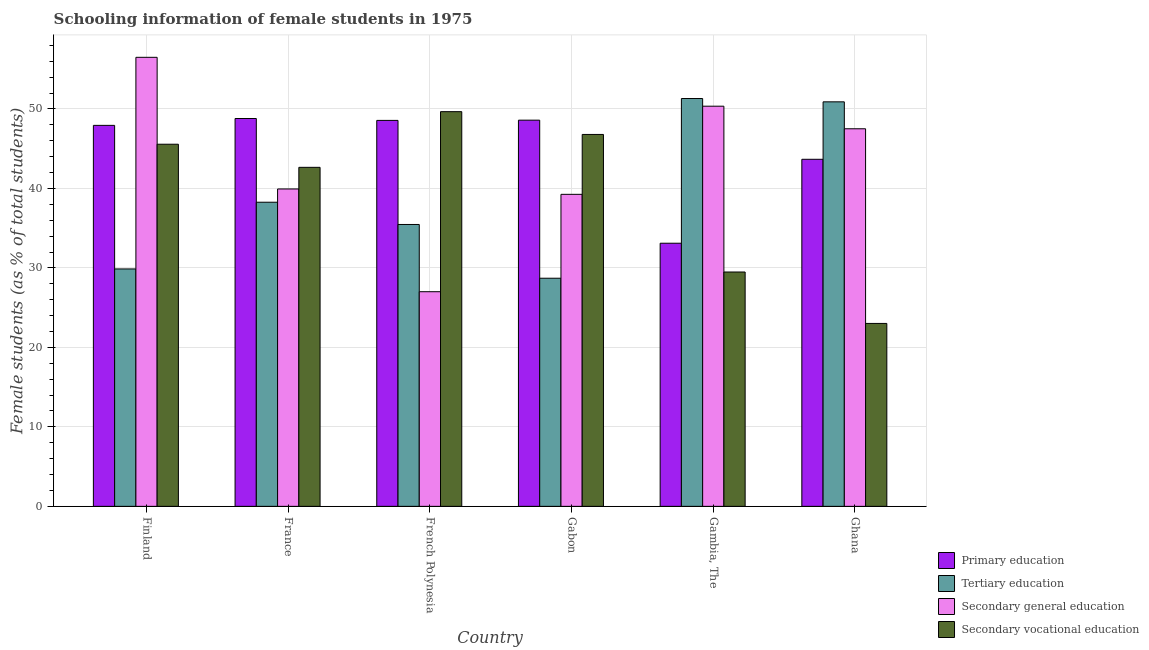How many different coloured bars are there?
Your response must be concise. 4. Are the number of bars on each tick of the X-axis equal?
Ensure brevity in your answer.  Yes. How many bars are there on the 1st tick from the left?
Your response must be concise. 4. How many bars are there on the 6th tick from the right?
Your answer should be very brief. 4. What is the label of the 1st group of bars from the left?
Make the answer very short. Finland. In how many cases, is the number of bars for a given country not equal to the number of legend labels?
Your answer should be very brief. 0. What is the percentage of female students in secondary vocational education in French Polynesia?
Keep it short and to the point. 49.66. Across all countries, what is the maximum percentage of female students in primary education?
Ensure brevity in your answer.  48.8. Across all countries, what is the minimum percentage of female students in secondary education?
Offer a very short reply. 27.01. In which country was the percentage of female students in secondary vocational education maximum?
Provide a succinct answer. French Polynesia. What is the total percentage of female students in secondary education in the graph?
Offer a very short reply. 260.57. What is the difference between the percentage of female students in secondary vocational education in France and that in Gambia, The?
Your answer should be compact. 13.17. What is the difference between the percentage of female students in tertiary education in Gambia, The and the percentage of female students in secondary vocational education in Gabon?
Offer a terse response. 4.52. What is the average percentage of female students in secondary education per country?
Your response must be concise. 43.43. What is the difference between the percentage of female students in secondary education and percentage of female students in primary education in Finland?
Your answer should be compact. 8.56. In how many countries, is the percentage of female students in tertiary education greater than 54 %?
Keep it short and to the point. 0. What is the ratio of the percentage of female students in secondary vocational education in Finland to that in French Polynesia?
Ensure brevity in your answer.  0.92. Is the percentage of female students in primary education in Finland less than that in Ghana?
Ensure brevity in your answer.  No. Is the difference between the percentage of female students in tertiary education in French Polynesia and Ghana greater than the difference between the percentage of female students in secondary vocational education in French Polynesia and Ghana?
Your answer should be compact. No. What is the difference between the highest and the second highest percentage of female students in tertiary education?
Your answer should be very brief. 0.42. What is the difference between the highest and the lowest percentage of female students in secondary vocational education?
Your answer should be compact. 26.65. Is it the case that in every country, the sum of the percentage of female students in tertiary education and percentage of female students in secondary vocational education is greater than the sum of percentage of female students in primary education and percentage of female students in secondary education?
Keep it short and to the point. Yes. What does the 3rd bar from the left in French Polynesia represents?
Offer a terse response. Secondary general education. What does the 3rd bar from the right in Finland represents?
Give a very brief answer. Tertiary education. How many bars are there?
Your response must be concise. 24. Are all the bars in the graph horizontal?
Your answer should be compact. No. How many countries are there in the graph?
Offer a terse response. 6. Are the values on the major ticks of Y-axis written in scientific E-notation?
Keep it short and to the point. No. Does the graph contain any zero values?
Keep it short and to the point. No. Does the graph contain grids?
Your response must be concise. Yes. How many legend labels are there?
Offer a very short reply. 4. What is the title of the graph?
Offer a terse response. Schooling information of female students in 1975. Does "Corruption" appear as one of the legend labels in the graph?
Your response must be concise. No. What is the label or title of the X-axis?
Your answer should be compact. Country. What is the label or title of the Y-axis?
Keep it short and to the point. Female students (as % of total students). What is the Female students (as % of total students) in Primary education in Finland?
Give a very brief answer. 47.94. What is the Female students (as % of total students) of Tertiary education in Finland?
Ensure brevity in your answer.  29.87. What is the Female students (as % of total students) of Secondary general education in Finland?
Offer a very short reply. 56.5. What is the Female students (as % of total students) of Secondary vocational education in Finland?
Your response must be concise. 45.57. What is the Female students (as % of total students) in Primary education in France?
Your answer should be compact. 48.8. What is the Female students (as % of total students) in Tertiary education in France?
Your answer should be very brief. 38.27. What is the Female students (as % of total students) of Secondary general education in France?
Ensure brevity in your answer.  39.94. What is the Female students (as % of total students) of Secondary vocational education in France?
Ensure brevity in your answer.  42.66. What is the Female students (as % of total students) in Primary education in French Polynesia?
Provide a short and direct response. 48.56. What is the Female students (as % of total students) of Tertiary education in French Polynesia?
Offer a very short reply. 35.47. What is the Female students (as % of total students) of Secondary general education in French Polynesia?
Ensure brevity in your answer.  27.01. What is the Female students (as % of total students) in Secondary vocational education in French Polynesia?
Give a very brief answer. 49.66. What is the Female students (as % of total students) in Primary education in Gabon?
Offer a very short reply. 48.59. What is the Female students (as % of total students) in Tertiary education in Gabon?
Offer a very short reply. 28.7. What is the Female students (as % of total students) in Secondary general education in Gabon?
Offer a terse response. 39.26. What is the Female students (as % of total students) of Secondary vocational education in Gabon?
Offer a terse response. 46.8. What is the Female students (as % of total students) in Primary education in Gambia, The?
Provide a succinct answer. 33.11. What is the Female students (as % of total students) of Tertiary education in Gambia, The?
Make the answer very short. 51.32. What is the Female students (as % of total students) in Secondary general education in Gambia, The?
Your answer should be very brief. 50.35. What is the Female students (as % of total students) in Secondary vocational education in Gambia, The?
Keep it short and to the point. 29.49. What is the Female students (as % of total students) in Primary education in Ghana?
Offer a terse response. 43.67. What is the Female students (as % of total students) of Tertiary education in Ghana?
Provide a short and direct response. 50.9. What is the Female students (as % of total students) of Secondary general education in Ghana?
Offer a very short reply. 47.51. What is the Female students (as % of total students) of Secondary vocational education in Ghana?
Provide a short and direct response. 23.02. Across all countries, what is the maximum Female students (as % of total students) of Primary education?
Keep it short and to the point. 48.8. Across all countries, what is the maximum Female students (as % of total students) in Tertiary education?
Keep it short and to the point. 51.32. Across all countries, what is the maximum Female students (as % of total students) in Secondary general education?
Offer a terse response. 56.5. Across all countries, what is the maximum Female students (as % of total students) in Secondary vocational education?
Offer a very short reply. 49.66. Across all countries, what is the minimum Female students (as % of total students) in Primary education?
Offer a very short reply. 33.11. Across all countries, what is the minimum Female students (as % of total students) of Tertiary education?
Make the answer very short. 28.7. Across all countries, what is the minimum Female students (as % of total students) in Secondary general education?
Provide a succinct answer. 27.01. Across all countries, what is the minimum Female students (as % of total students) of Secondary vocational education?
Give a very brief answer. 23.02. What is the total Female students (as % of total students) of Primary education in the graph?
Your response must be concise. 270.67. What is the total Female students (as % of total students) in Tertiary education in the graph?
Offer a terse response. 234.53. What is the total Female students (as % of total students) in Secondary general education in the graph?
Offer a very short reply. 260.57. What is the total Female students (as % of total students) of Secondary vocational education in the graph?
Provide a short and direct response. 237.18. What is the difference between the Female students (as % of total students) of Primary education in Finland and that in France?
Your answer should be compact. -0.86. What is the difference between the Female students (as % of total students) of Tertiary education in Finland and that in France?
Your answer should be very brief. -8.4. What is the difference between the Female students (as % of total students) of Secondary general education in Finland and that in France?
Provide a succinct answer. 16.56. What is the difference between the Female students (as % of total students) in Secondary vocational education in Finland and that in France?
Make the answer very short. 2.91. What is the difference between the Female students (as % of total students) in Primary education in Finland and that in French Polynesia?
Keep it short and to the point. -0.62. What is the difference between the Female students (as % of total students) of Tertiary education in Finland and that in French Polynesia?
Your answer should be very brief. -5.6. What is the difference between the Female students (as % of total students) of Secondary general education in Finland and that in French Polynesia?
Keep it short and to the point. 29.49. What is the difference between the Female students (as % of total students) of Secondary vocational education in Finland and that in French Polynesia?
Provide a succinct answer. -4.1. What is the difference between the Female students (as % of total students) of Primary education in Finland and that in Gabon?
Provide a succinct answer. -0.65. What is the difference between the Female students (as % of total students) of Tertiary education in Finland and that in Gabon?
Your response must be concise. 1.17. What is the difference between the Female students (as % of total students) in Secondary general education in Finland and that in Gabon?
Provide a succinct answer. 17.24. What is the difference between the Female students (as % of total students) in Secondary vocational education in Finland and that in Gabon?
Your answer should be very brief. -1.23. What is the difference between the Female students (as % of total students) in Primary education in Finland and that in Gambia, The?
Provide a succinct answer. 14.83. What is the difference between the Female students (as % of total students) of Tertiary education in Finland and that in Gambia, The?
Ensure brevity in your answer.  -21.44. What is the difference between the Female students (as % of total students) of Secondary general education in Finland and that in Gambia, The?
Keep it short and to the point. 6.15. What is the difference between the Female students (as % of total students) of Secondary vocational education in Finland and that in Gambia, The?
Your answer should be very brief. 16.08. What is the difference between the Female students (as % of total students) in Primary education in Finland and that in Ghana?
Keep it short and to the point. 4.27. What is the difference between the Female students (as % of total students) in Tertiary education in Finland and that in Ghana?
Offer a very short reply. -21.03. What is the difference between the Female students (as % of total students) in Secondary general education in Finland and that in Ghana?
Provide a short and direct response. 8.99. What is the difference between the Female students (as % of total students) in Secondary vocational education in Finland and that in Ghana?
Provide a short and direct response. 22.55. What is the difference between the Female students (as % of total students) in Primary education in France and that in French Polynesia?
Give a very brief answer. 0.24. What is the difference between the Female students (as % of total students) in Tertiary education in France and that in French Polynesia?
Your response must be concise. 2.8. What is the difference between the Female students (as % of total students) in Secondary general education in France and that in French Polynesia?
Offer a very short reply. 12.93. What is the difference between the Female students (as % of total students) of Secondary vocational education in France and that in French Polynesia?
Your answer should be compact. -7.01. What is the difference between the Female students (as % of total students) in Primary education in France and that in Gabon?
Provide a short and direct response. 0.21. What is the difference between the Female students (as % of total students) in Tertiary education in France and that in Gabon?
Make the answer very short. 9.56. What is the difference between the Female students (as % of total students) of Secondary general education in France and that in Gabon?
Provide a short and direct response. 0.68. What is the difference between the Female students (as % of total students) in Secondary vocational education in France and that in Gabon?
Keep it short and to the point. -4.14. What is the difference between the Female students (as % of total students) in Primary education in France and that in Gambia, The?
Your answer should be very brief. 15.69. What is the difference between the Female students (as % of total students) in Tertiary education in France and that in Gambia, The?
Offer a terse response. -13.05. What is the difference between the Female students (as % of total students) of Secondary general education in France and that in Gambia, The?
Provide a succinct answer. -10.41. What is the difference between the Female students (as % of total students) of Secondary vocational education in France and that in Gambia, The?
Offer a terse response. 13.17. What is the difference between the Female students (as % of total students) of Primary education in France and that in Ghana?
Offer a very short reply. 5.13. What is the difference between the Female students (as % of total students) of Tertiary education in France and that in Ghana?
Provide a short and direct response. -12.63. What is the difference between the Female students (as % of total students) in Secondary general education in France and that in Ghana?
Your answer should be very brief. -7.57. What is the difference between the Female students (as % of total students) of Secondary vocational education in France and that in Ghana?
Give a very brief answer. 19.64. What is the difference between the Female students (as % of total students) of Primary education in French Polynesia and that in Gabon?
Your response must be concise. -0.03. What is the difference between the Female students (as % of total students) in Tertiary education in French Polynesia and that in Gabon?
Ensure brevity in your answer.  6.76. What is the difference between the Female students (as % of total students) in Secondary general education in French Polynesia and that in Gabon?
Your answer should be very brief. -12.25. What is the difference between the Female students (as % of total students) of Secondary vocational education in French Polynesia and that in Gabon?
Offer a terse response. 2.87. What is the difference between the Female students (as % of total students) of Primary education in French Polynesia and that in Gambia, The?
Keep it short and to the point. 15.46. What is the difference between the Female students (as % of total students) of Tertiary education in French Polynesia and that in Gambia, The?
Provide a succinct answer. -15.85. What is the difference between the Female students (as % of total students) in Secondary general education in French Polynesia and that in Gambia, The?
Ensure brevity in your answer.  -23.34. What is the difference between the Female students (as % of total students) in Secondary vocational education in French Polynesia and that in Gambia, The?
Offer a very short reply. 20.18. What is the difference between the Female students (as % of total students) in Primary education in French Polynesia and that in Ghana?
Offer a very short reply. 4.89. What is the difference between the Female students (as % of total students) in Tertiary education in French Polynesia and that in Ghana?
Offer a terse response. -15.43. What is the difference between the Female students (as % of total students) of Secondary general education in French Polynesia and that in Ghana?
Make the answer very short. -20.5. What is the difference between the Female students (as % of total students) of Secondary vocational education in French Polynesia and that in Ghana?
Offer a terse response. 26.65. What is the difference between the Female students (as % of total students) of Primary education in Gabon and that in Gambia, The?
Provide a short and direct response. 15.49. What is the difference between the Female students (as % of total students) of Tertiary education in Gabon and that in Gambia, The?
Your answer should be very brief. -22.61. What is the difference between the Female students (as % of total students) of Secondary general education in Gabon and that in Gambia, The?
Your answer should be compact. -11.09. What is the difference between the Female students (as % of total students) in Secondary vocational education in Gabon and that in Gambia, The?
Give a very brief answer. 17.31. What is the difference between the Female students (as % of total students) in Primary education in Gabon and that in Ghana?
Offer a terse response. 4.92. What is the difference between the Female students (as % of total students) of Tertiary education in Gabon and that in Ghana?
Provide a succinct answer. -22.2. What is the difference between the Female students (as % of total students) in Secondary general education in Gabon and that in Ghana?
Provide a short and direct response. -8.25. What is the difference between the Female students (as % of total students) of Secondary vocational education in Gabon and that in Ghana?
Your answer should be very brief. 23.78. What is the difference between the Female students (as % of total students) of Primary education in Gambia, The and that in Ghana?
Offer a very short reply. -10.56. What is the difference between the Female students (as % of total students) of Tertiary education in Gambia, The and that in Ghana?
Provide a short and direct response. 0.42. What is the difference between the Female students (as % of total students) of Secondary general education in Gambia, The and that in Ghana?
Your answer should be compact. 2.84. What is the difference between the Female students (as % of total students) in Secondary vocational education in Gambia, The and that in Ghana?
Offer a very short reply. 6.47. What is the difference between the Female students (as % of total students) in Primary education in Finland and the Female students (as % of total students) in Tertiary education in France?
Offer a very short reply. 9.67. What is the difference between the Female students (as % of total students) of Primary education in Finland and the Female students (as % of total students) of Secondary general education in France?
Your answer should be very brief. 8. What is the difference between the Female students (as % of total students) of Primary education in Finland and the Female students (as % of total students) of Secondary vocational education in France?
Provide a succinct answer. 5.28. What is the difference between the Female students (as % of total students) in Tertiary education in Finland and the Female students (as % of total students) in Secondary general education in France?
Provide a short and direct response. -10.07. What is the difference between the Female students (as % of total students) of Tertiary education in Finland and the Female students (as % of total students) of Secondary vocational education in France?
Your answer should be very brief. -12.79. What is the difference between the Female students (as % of total students) of Secondary general education in Finland and the Female students (as % of total students) of Secondary vocational education in France?
Offer a terse response. 13.84. What is the difference between the Female students (as % of total students) in Primary education in Finland and the Female students (as % of total students) in Tertiary education in French Polynesia?
Keep it short and to the point. 12.47. What is the difference between the Female students (as % of total students) in Primary education in Finland and the Female students (as % of total students) in Secondary general education in French Polynesia?
Give a very brief answer. 20.93. What is the difference between the Female students (as % of total students) in Primary education in Finland and the Female students (as % of total students) in Secondary vocational education in French Polynesia?
Your response must be concise. -1.72. What is the difference between the Female students (as % of total students) in Tertiary education in Finland and the Female students (as % of total students) in Secondary general education in French Polynesia?
Give a very brief answer. 2.86. What is the difference between the Female students (as % of total students) in Tertiary education in Finland and the Female students (as % of total students) in Secondary vocational education in French Polynesia?
Ensure brevity in your answer.  -19.79. What is the difference between the Female students (as % of total students) of Secondary general education in Finland and the Female students (as % of total students) of Secondary vocational education in French Polynesia?
Make the answer very short. 6.84. What is the difference between the Female students (as % of total students) of Primary education in Finland and the Female students (as % of total students) of Tertiary education in Gabon?
Provide a short and direct response. 19.24. What is the difference between the Female students (as % of total students) of Primary education in Finland and the Female students (as % of total students) of Secondary general education in Gabon?
Your answer should be compact. 8.68. What is the difference between the Female students (as % of total students) in Tertiary education in Finland and the Female students (as % of total students) in Secondary general education in Gabon?
Your response must be concise. -9.39. What is the difference between the Female students (as % of total students) of Tertiary education in Finland and the Female students (as % of total students) of Secondary vocational education in Gabon?
Provide a short and direct response. -16.92. What is the difference between the Female students (as % of total students) in Secondary general education in Finland and the Female students (as % of total students) in Secondary vocational education in Gabon?
Your answer should be very brief. 9.7. What is the difference between the Female students (as % of total students) of Primary education in Finland and the Female students (as % of total students) of Tertiary education in Gambia, The?
Your answer should be compact. -3.38. What is the difference between the Female students (as % of total students) in Primary education in Finland and the Female students (as % of total students) in Secondary general education in Gambia, The?
Your answer should be compact. -2.41. What is the difference between the Female students (as % of total students) in Primary education in Finland and the Female students (as % of total students) in Secondary vocational education in Gambia, The?
Offer a very short reply. 18.45. What is the difference between the Female students (as % of total students) in Tertiary education in Finland and the Female students (as % of total students) in Secondary general education in Gambia, The?
Provide a succinct answer. -20.48. What is the difference between the Female students (as % of total students) in Tertiary education in Finland and the Female students (as % of total students) in Secondary vocational education in Gambia, The?
Provide a short and direct response. 0.38. What is the difference between the Female students (as % of total students) in Secondary general education in Finland and the Female students (as % of total students) in Secondary vocational education in Gambia, The?
Keep it short and to the point. 27.01. What is the difference between the Female students (as % of total students) of Primary education in Finland and the Female students (as % of total students) of Tertiary education in Ghana?
Offer a terse response. -2.96. What is the difference between the Female students (as % of total students) of Primary education in Finland and the Female students (as % of total students) of Secondary general education in Ghana?
Make the answer very short. 0.43. What is the difference between the Female students (as % of total students) in Primary education in Finland and the Female students (as % of total students) in Secondary vocational education in Ghana?
Keep it short and to the point. 24.92. What is the difference between the Female students (as % of total students) of Tertiary education in Finland and the Female students (as % of total students) of Secondary general education in Ghana?
Your response must be concise. -17.64. What is the difference between the Female students (as % of total students) of Tertiary education in Finland and the Female students (as % of total students) of Secondary vocational education in Ghana?
Your answer should be very brief. 6.86. What is the difference between the Female students (as % of total students) of Secondary general education in Finland and the Female students (as % of total students) of Secondary vocational education in Ghana?
Make the answer very short. 33.48. What is the difference between the Female students (as % of total students) in Primary education in France and the Female students (as % of total students) in Tertiary education in French Polynesia?
Provide a succinct answer. 13.33. What is the difference between the Female students (as % of total students) in Primary education in France and the Female students (as % of total students) in Secondary general education in French Polynesia?
Offer a very short reply. 21.79. What is the difference between the Female students (as % of total students) in Primary education in France and the Female students (as % of total students) in Secondary vocational education in French Polynesia?
Your answer should be compact. -0.86. What is the difference between the Female students (as % of total students) in Tertiary education in France and the Female students (as % of total students) in Secondary general education in French Polynesia?
Your answer should be very brief. 11.26. What is the difference between the Female students (as % of total students) in Tertiary education in France and the Female students (as % of total students) in Secondary vocational education in French Polynesia?
Your answer should be very brief. -11.4. What is the difference between the Female students (as % of total students) of Secondary general education in France and the Female students (as % of total students) of Secondary vocational education in French Polynesia?
Offer a terse response. -9.73. What is the difference between the Female students (as % of total students) in Primary education in France and the Female students (as % of total students) in Tertiary education in Gabon?
Your response must be concise. 20.1. What is the difference between the Female students (as % of total students) in Primary education in France and the Female students (as % of total students) in Secondary general education in Gabon?
Provide a short and direct response. 9.54. What is the difference between the Female students (as % of total students) in Primary education in France and the Female students (as % of total students) in Secondary vocational education in Gabon?
Your answer should be very brief. 2.01. What is the difference between the Female students (as % of total students) in Tertiary education in France and the Female students (as % of total students) in Secondary general education in Gabon?
Your response must be concise. -0.99. What is the difference between the Female students (as % of total students) of Tertiary education in France and the Female students (as % of total students) of Secondary vocational education in Gabon?
Your response must be concise. -8.53. What is the difference between the Female students (as % of total students) of Secondary general education in France and the Female students (as % of total students) of Secondary vocational education in Gabon?
Ensure brevity in your answer.  -6.86. What is the difference between the Female students (as % of total students) of Primary education in France and the Female students (as % of total students) of Tertiary education in Gambia, The?
Offer a very short reply. -2.51. What is the difference between the Female students (as % of total students) in Primary education in France and the Female students (as % of total students) in Secondary general education in Gambia, The?
Your answer should be very brief. -1.55. What is the difference between the Female students (as % of total students) of Primary education in France and the Female students (as % of total students) of Secondary vocational education in Gambia, The?
Make the answer very short. 19.31. What is the difference between the Female students (as % of total students) in Tertiary education in France and the Female students (as % of total students) in Secondary general education in Gambia, The?
Offer a terse response. -12.08. What is the difference between the Female students (as % of total students) in Tertiary education in France and the Female students (as % of total students) in Secondary vocational education in Gambia, The?
Your response must be concise. 8.78. What is the difference between the Female students (as % of total students) of Secondary general education in France and the Female students (as % of total students) of Secondary vocational education in Gambia, The?
Provide a short and direct response. 10.45. What is the difference between the Female students (as % of total students) of Primary education in France and the Female students (as % of total students) of Tertiary education in Ghana?
Offer a very short reply. -2.1. What is the difference between the Female students (as % of total students) in Primary education in France and the Female students (as % of total students) in Secondary general education in Ghana?
Your answer should be very brief. 1.29. What is the difference between the Female students (as % of total students) in Primary education in France and the Female students (as % of total students) in Secondary vocational education in Ghana?
Give a very brief answer. 25.79. What is the difference between the Female students (as % of total students) in Tertiary education in France and the Female students (as % of total students) in Secondary general education in Ghana?
Provide a short and direct response. -9.24. What is the difference between the Female students (as % of total students) of Tertiary education in France and the Female students (as % of total students) of Secondary vocational education in Ghana?
Give a very brief answer. 15.25. What is the difference between the Female students (as % of total students) of Secondary general education in France and the Female students (as % of total students) of Secondary vocational education in Ghana?
Your answer should be very brief. 16.92. What is the difference between the Female students (as % of total students) in Primary education in French Polynesia and the Female students (as % of total students) in Tertiary education in Gabon?
Ensure brevity in your answer.  19.86. What is the difference between the Female students (as % of total students) in Primary education in French Polynesia and the Female students (as % of total students) in Secondary general education in Gabon?
Give a very brief answer. 9.3. What is the difference between the Female students (as % of total students) of Primary education in French Polynesia and the Female students (as % of total students) of Secondary vocational education in Gabon?
Ensure brevity in your answer.  1.77. What is the difference between the Female students (as % of total students) of Tertiary education in French Polynesia and the Female students (as % of total students) of Secondary general education in Gabon?
Offer a very short reply. -3.79. What is the difference between the Female students (as % of total students) in Tertiary education in French Polynesia and the Female students (as % of total students) in Secondary vocational education in Gabon?
Give a very brief answer. -11.33. What is the difference between the Female students (as % of total students) in Secondary general education in French Polynesia and the Female students (as % of total students) in Secondary vocational education in Gabon?
Your answer should be compact. -19.79. What is the difference between the Female students (as % of total students) in Primary education in French Polynesia and the Female students (as % of total students) in Tertiary education in Gambia, The?
Keep it short and to the point. -2.75. What is the difference between the Female students (as % of total students) of Primary education in French Polynesia and the Female students (as % of total students) of Secondary general education in Gambia, The?
Your answer should be very brief. -1.79. What is the difference between the Female students (as % of total students) in Primary education in French Polynesia and the Female students (as % of total students) in Secondary vocational education in Gambia, The?
Make the answer very short. 19.08. What is the difference between the Female students (as % of total students) in Tertiary education in French Polynesia and the Female students (as % of total students) in Secondary general education in Gambia, The?
Your answer should be compact. -14.88. What is the difference between the Female students (as % of total students) in Tertiary education in French Polynesia and the Female students (as % of total students) in Secondary vocational education in Gambia, The?
Your answer should be compact. 5.98. What is the difference between the Female students (as % of total students) of Secondary general education in French Polynesia and the Female students (as % of total students) of Secondary vocational education in Gambia, The?
Provide a succinct answer. -2.48. What is the difference between the Female students (as % of total students) of Primary education in French Polynesia and the Female students (as % of total students) of Tertiary education in Ghana?
Your answer should be very brief. -2.34. What is the difference between the Female students (as % of total students) of Primary education in French Polynesia and the Female students (as % of total students) of Secondary general education in Ghana?
Offer a very short reply. 1.05. What is the difference between the Female students (as % of total students) of Primary education in French Polynesia and the Female students (as % of total students) of Secondary vocational education in Ghana?
Your response must be concise. 25.55. What is the difference between the Female students (as % of total students) in Tertiary education in French Polynesia and the Female students (as % of total students) in Secondary general education in Ghana?
Offer a terse response. -12.04. What is the difference between the Female students (as % of total students) in Tertiary education in French Polynesia and the Female students (as % of total students) in Secondary vocational education in Ghana?
Keep it short and to the point. 12.45. What is the difference between the Female students (as % of total students) of Secondary general education in French Polynesia and the Female students (as % of total students) of Secondary vocational education in Ghana?
Provide a short and direct response. 3.99. What is the difference between the Female students (as % of total students) in Primary education in Gabon and the Female students (as % of total students) in Tertiary education in Gambia, The?
Your response must be concise. -2.72. What is the difference between the Female students (as % of total students) in Primary education in Gabon and the Female students (as % of total students) in Secondary general education in Gambia, The?
Your answer should be compact. -1.76. What is the difference between the Female students (as % of total students) of Primary education in Gabon and the Female students (as % of total students) of Secondary vocational education in Gambia, The?
Your response must be concise. 19.11. What is the difference between the Female students (as % of total students) in Tertiary education in Gabon and the Female students (as % of total students) in Secondary general education in Gambia, The?
Provide a succinct answer. -21.65. What is the difference between the Female students (as % of total students) in Tertiary education in Gabon and the Female students (as % of total students) in Secondary vocational education in Gambia, The?
Your answer should be very brief. -0.78. What is the difference between the Female students (as % of total students) of Secondary general education in Gabon and the Female students (as % of total students) of Secondary vocational education in Gambia, The?
Keep it short and to the point. 9.77. What is the difference between the Female students (as % of total students) of Primary education in Gabon and the Female students (as % of total students) of Tertiary education in Ghana?
Keep it short and to the point. -2.31. What is the difference between the Female students (as % of total students) in Primary education in Gabon and the Female students (as % of total students) in Secondary general education in Ghana?
Offer a terse response. 1.08. What is the difference between the Female students (as % of total students) in Primary education in Gabon and the Female students (as % of total students) in Secondary vocational education in Ghana?
Keep it short and to the point. 25.58. What is the difference between the Female students (as % of total students) of Tertiary education in Gabon and the Female students (as % of total students) of Secondary general education in Ghana?
Your answer should be very brief. -18.81. What is the difference between the Female students (as % of total students) of Tertiary education in Gabon and the Female students (as % of total students) of Secondary vocational education in Ghana?
Ensure brevity in your answer.  5.69. What is the difference between the Female students (as % of total students) of Secondary general education in Gabon and the Female students (as % of total students) of Secondary vocational education in Ghana?
Provide a succinct answer. 16.25. What is the difference between the Female students (as % of total students) in Primary education in Gambia, The and the Female students (as % of total students) in Tertiary education in Ghana?
Provide a short and direct response. -17.79. What is the difference between the Female students (as % of total students) of Primary education in Gambia, The and the Female students (as % of total students) of Secondary general education in Ghana?
Provide a short and direct response. -14.4. What is the difference between the Female students (as % of total students) of Primary education in Gambia, The and the Female students (as % of total students) of Secondary vocational education in Ghana?
Your response must be concise. 10.09. What is the difference between the Female students (as % of total students) of Tertiary education in Gambia, The and the Female students (as % of total students) of Secondary general education in Ghana?
Make the answer very short. 3.81. What is the difference between the Female students (as % of total students) in Tertiary education in Gambia, The and the Female students (as % of total students) in Secondary vocational education in Ghana?
Your response must be concise. 28.3. What is the difference between the Female students (as % of total students) of Secondary general education in Gambia, The and the Female students (as % of total students) of Secondary vocational education in Ghana?
Offer a very short reply. 27.34. What is the average Female students (as % of total students) of Primary education per country?
Give a very brief answer. 45.11. What is the average Female students (as % of total students) in Tertiary education per country?
Provide a succinct answer. 39.09. What is the average Female students (as % of total students) of Secondary general education per country?
Make the answer very short. 43.43. What is the average Female students (as % of total students) of Secondary vocational education per country?
Keep it short and to the point. 39.53. What is the difference between the Female students (as % of total students) in Primary education and Female students (as % of total students) in Tertiary education in Finland?
Make the answer very short. 18.07. What is the difference between the Female students (as % of total students) in Primary education and Female students (as % of total students) in Secondary general education in Finland?
Keep it short and to the point. -8.56. What is the difference between the Female students (as % of total students) in Primary education and Female students (as % of total students) in Secondary vocational education in Finland?
Your answer should be compact. 2.37. What is the difference between the Female students (as % of total students) of Tertiary education and Female students (as % of total students) of Secondary general education in Finland?
Your answer should be compact. -26.63. What is the difference between the Female students (as % of total students) in Tertiary education and Female students (as % of total students) in Secondary vocational education in Finland?
Provide a succinct answer. -15.69. What is the difference between the Female students (as % of total students) in Secondary general education and Female students (as % of total students) in Secondary vocational education in Finland?
Your response must be concise. 10.94. What is the difference between the Female students (as % of total students) in Primary education and Female students (as % of total students) in Tertiary education in France?
Provide a short and direct response. 10.53. What is the difference between the Female students (as % of total students) of Primary education and Female students (as % of total students) of Secondary general education in France?
Offer a very short reply. 8.86. What is the difference between the Female students (as % of total students) of Primary education and Female students (as % of total students) of Secondary vocational education in France?
Offer a very short reply. 6.14. What is the difference between the Female students (as % of total students) in Tertiary education and Female students (as % of total students) in Secondary general education in France?
Your response must be concise. -1.67. What is the difference between the Female students (as % of total students) of Tertiary education and Female students (as % of total students) of Secondary vocational education in France?
Give a very brief answer. -4.39. What is the difference between the Female students (as % of total students) in Secondary general education and Female students (as % of total students) in Secondary vocational education in France?
Your response must be concise. -2.72. What is the difference between the Female students (as % of total students) of Primary education and Female students (as % of total students) of Tertiary education in French Polynesia?
Ensure brevity in your answer.  13.1. What is the difference between the Female students (as % of total students) of Primary education and Female students (as % of total students) of Secondary general education in French Polynesia?
Your answer should be compact. 21.56. What is the difference between the Female students (as % of total students) of Primary education and Female students (as % of total students) of Secondary vocational education in French Polynesia?
Offer a terse response. -1.1. What is the difference between the Female students (as % of total students) of Tertiary education and Female students (as % of total students) of Secondary general education in French Polynesia?
Keep it short and to the point. 8.46. What is the difference between the Female students (as % of total students) in Tertiary education and Female students (as % of total students) in Secondary vocational education in French Polynesia?
Offer a terse response. -14.2. What is the difference between the Female students (as % of total students) in Secondary general education and Female students (as % of total students) in Secondary vocational education in French Polynesia?
Make the answer very short. -22.66. What is the difference between the Female students (as % of total students) in Primary education and Female students (as % of total students) in Tertiary education in Gabon?
Offer a very short reply. 19.89. What is the difference between the Female students (as % of total students) in Primary education and Female students (as % of total students) in Secondary general education in Gabon?
Offer a very short reply. 9.33. What is the difference between the Female students (as % of total students) in Primary education and Female students (as % of total students) in Secondary vocational education in Gabon?
Provide a short and direct response. 1.8. What is the difference between the Female students (as % of total students) of Tertiary education and Female students (as % of total students) of Secondary general education in Gabon?
Your response must be concise. -10.56. What is the difference between the Female students (as % of total students) of Tertiary education and Female students (as % of total students) of Secondary vocational education in Gabon?
Your response must be concise. -18.09. What is the difference between the Female students (as % of total students) of Secondary general education and Female students (as % of total students) of Secondary vocational education in Gabon?
Offer a very short reply. -7.53. What is the difference between the Female students (as % of total students) of Primary education and Female students (as % of total students) of Tertiary education in Gambia, The?
Ensure brevity in your answer.  -18.21. What is the difference between the Female students (as % of total students) of Primary education and Female students (as % of total students) of Secondary general education in Gambia, The?
Offer a very short reply. -17.24. What is the difference between the Female students (as % of total students) in Primary education and Female students (as % of total students) in Secondary vocational education in Gambia, The?
Keep it short and to the point. 3.62. What is the difference between the Female students (as % of total students) in Tertiary education and Female students (as % of total students) in Secondary general education in Gambia, The?
Offer a terse response. 0.96. What is the difference between the Female students (as % of total students) of Tertiary education and Female students (as % of total students) of Secondary vocational education in Gambia, The?
Make the answer very short. 21.83. What is the difference between the Female students (as % of total students) of Secondary general education and Female students (as % of total students) of Secondary vocational education in Gambia, The?
Keep it short and to the point. 20.86. What is the difference between the Female students (as % of total students) of Primary education and Female students (as % of total students) of Tertiary education in Ghana?
Offer a terse response. -7.23. What is the difference between the Female students (as % of total students) of Primary education and Female students (as % of total students) of Secondary general education in Ghana?
Ensure brevity in your answer.  -3.84. What is the difference between the Female students (as % of total students) in Primary education and Female students (as % of total students) in Secondary vocational education in Ghana?
Provide a short and direct response. 20.65. What is the difference between the Female students (as % of total students) in Tertiary education and Female students (as % of total students) in Secondary general education in Ghana?
Keep it short and to the point. 3.39. What is the difference between the Female students (as % of total students) in Tertiary education and Female students (as % of total students) in Secondary vocational education in Ghana?
Your answer should be very brief. 27.88. What is the difference between the Female students (as % of total students) in Secondary general education and Female students (as % of total students) in Secondary vocational education in Ghana?
Provide a short and direct response. 24.49. What is the ratio of the Female students (as % of total students) of Primary education in Finland to that in France?
Your answer should be very brief. 0.98. What is the ratio of the Female students (as % of total students) of Tertiary education in Finland to that in France?
Provide a short and direct response. 0.78. What is the ratio of the Female students (as % of total students) in Secondary general education in Finland to that in France?
Make the answer very short. 1.41. What is the ratio of the Female students (as % of total students) of Secondary vocational education in Finland to that in France?
Your answer should be compact. 1.07. What is the ratio of the Female students (as % of total students) in Primary education in Finland to that in French Polynesia?
Your answer should be compact. 0.99. What is the ratio of the Female students (as % of total students) of Tertiary education in Finland to that in French Polynesia?
Provide a succinct answer. 0.84. What is the ratio of the Female students (as % of total students) in Secondary general education in Finland to that in French Polynesia?
Keep it short and to the point. 2.09. What is the ratio of the Female students (as % of total students) in Secondary vocational education in Finland to that in French Polynesia?
Offer a terse response. 0.92. What is the ratio of the Female students (as % of total students) in Primary education in Finland to that in Gabon?
Your answer should be compact. 0.99. What is the ratio of the Female students (as % of total students) of Tertiary education in Finland to that in Gabon?
Offer a terse response. 1.04. What is the ratio of the Female students (as % of total students) in Secondary general education in Finland to that in Gabon?
Provide a short and direct response. 1.44. What is the ratio of the Female students (as % of total students) in Secondary vocational education in Finland to that in Gabon?
Your response must be concise. 0.97. What is the ratio of the Female students (as % of total students) in Primary education in Finland to that in Gambia, The?
Your answer should be compact. 1.45. What is the ratio of the Female students (as % of total students) of Tertiary education in Finland to that in Gambia, The?
Provide a succinct answer. 0.58. What is the ratio of the Female students (as % of total students) in Secondary general education in Finland to that in Gambia, The?
Give a very brief answer. 1.12. What is the ratio of the Female students (as % of total students) in Secondary vocational education in Finland to that in Gambia, The?
Provide a succinct answer. 1.55. What is the ratio of the Female students (as % of total students) in Primary education in Finland to that in Ghana?
Offer a very short reply. 1.1. What is the ratio of the Female students (as % of total students) of Tertiary education in Finland to that in Ghana?
Provide a short and direct response. 0.59. What is the ratio of the Female students (as % of total students) of Secondary general education in Finland to that in Ghana?
Your answer should be compact. 1.19. What is the ratio of the Female students (as % of total students) in Secondary vocational education in Finland to that in Ghana?
Your answer should be very brief. 1.98. What is the ratio of the Female students (as % of total students) of Tertiary education in France to that in French Polynesia?
Give a very brief answer. 1.08. What is the ratio of the Female students (as % of total students) of Secondary general education in France to that in French Polynesia?
Make the answer very short. 1.48. What is the ratio of the Female students (as % of total students) of Secondary vocational education in France to that in French Polynesia?
Your response must be concise. 0.86. What is the ratio of the Female students (as % of total students) of Tertiary education in France to that in Gabon?
Your answer should be very brief. 1.33. What is the ratio of the Female students (as % of total students) in Secondary general education in France to that in Gabon?
Provide a succinct answer. 1.02. What is the ratio of the Female students (as % of total students) in Secondary vocational education in France to that in Gabon?
Give a very brief answer. 0.91. What is the ratio of the Female students (as % of total students) in Primary education in France to that in Gambia, The?
Make the answer very short. 1.47. What is the ratio of the Female students (as % of total students) in Tertiary education in France to that in Gambia, The?
Provide a succinct answer. 0.75. What is the ratio of the Female students (as % of total students) in Secondary general education in France to that in Gambia, The?
Your answer should be very brief. 0.79. What is the ratio of the Female students (as % of total students) in Secondary vocational education in France to that in Gambia, The?
Your answer should be very brief. 1.45. What is the ratio of the Female students (as % of total students) of Primary education in France to that in Ghana?
Your answer should be very brief. 1.12. What is the ratio of the Female students (as % of total students) of Tertiary education in France to that in Ghana?
Provide a short and direct response. 0.75. What is the ratio of the Female students (as % of total students) of Secondary general education in France to that in Ghana?
Provide a short and direct response. 0.84. What is the ratio of the Female students (as % of total students) in Secondary vocational education in France to that in Ghana?
Provide a short and direct response. 1.85. What is the ratio of the Female students (as % of total students) in Primary education in French Polynesia to that in Gabon?
Make the answer very short. 1. What is the ratio of the Female students (as % of total students) of Tertiary education in French Polynesia to that in Gabon?
Provide a short and direct response. 1.24. What is the ratio of the Female students (as % of total students) of Secondary general education in French Polynesia to that in Gabon?
Give a very brief answer. 0.69. What is the ratio of the Female students (as % of total students) of Secondary vocational education in French Polynesia to that in Gabon?
Make the answer very short. 1.06. What is the ratio of the Female students (as % of total students) of Primary education in French Polynesia to that in Gambia, The?
Provide a succinct answer. 1.47. What is the ratio of the Female students (as % of total students) in Tertiary education in French Polynesia to that in Gambia, The?
Keep it short and to the point. 0.69. What is the ratio of the Female students (as % of total students) of Secondary general education in French Polynesia to that in Gambia, The?
Your response must be concise. 0.54. What is the ratio of the Female students (as % of total students) of Secondary vocational education in French Polynesia to that in Gambia, The?
Keep it short and to the point. 1.68. What is the ratio of the Female students (as % of total students) in Primary education in French Polynesia to that in Ghana?
Provide a succinct answer. 1.11. What is the ratio of the Female students (as % of total students) of Tertiary education in French Polynesia to that in Ghana?
Your response must be concise. 0.7. What is the ratio of the Female students (as % of total students) of Secondary general education in French Polynesia to that in Ghana?
Keep it short and to the point. 0.57. What is the ratio of the Female students (as % of total students) of Secondary vocational education in French Polynesia to that in Ghana?
Your response must be concise. 2.16. What is the ratio of the Female students (as % of total students) in Primary education in Gabon to that in Gambia, The?
Your answer should be very brief. 1.47. What is the ratio of the Female students (as % of total students) of Tertiary education in Gabon to that in Gambia, The?
Your answer should be very brief. 0.56. What is the ratio of the Female students (as % of total students) in Secondary general education in Gabon to that in Gambia, The?
Your response must be concise. 0.78. What is the ratio of the Female students (as % of total students) in Secondary vocational education in Gabon to that in Gambia, The?
Your answer should be compact. 1.59. What is the ratio of the Female students (as % of total students) of Primary education in Gabon to that in Ghana?
Offer a terse response. 1.11. What is the ratio of the Female students (as % of total students) in Tertiary education in Gabon to that in Ghana?
Make the answer very short. 0.56. What is the ratio of the Female students (as % of total students) of Secondary general education in Gabon to that in Ghana?
Ensure brevity in your answer.  0.83. What is the ratio of the Female students (as % of total students) in Secondary vocational education in Gabon to that in Ghana?
Offer a terse response. 2.03. What is the ratio of the Female students (as % of total students) in Primary education in Gambia, The to that in Ghana?
Keep it short and to the point. 0.76. What is the ratio of the Female students (as % of total students) of Tertiary education in Gambia, The to that in Ghana?
Offer a very short reply. 1.01. What is the ratio of the Female students (as % of total students) of Secondary general education in Gambia, The to that in Ghana?
Your answer should be compact. 1.06. What is the ratio of the Female students (as % of total students) of Secondary vocational education in Gambia, The to that in Ghana?
Make the answer very short. 1.28. What is the difference between the highest and the second highest Female students (as % of total students) in Primary education?
Provide a succinct answer. 0.21. What is the difference between the highest and the second highest Female students (as % of total students) of Tertiary education?
Provide a succinct answer. 0.42. What is the difference between the highest and the second highest Female students (as % of total students) in Secondary general education?
Ensure brevity in your answer.  6.15. What is the difference between the highest and the second highest Female students (as % of total students) of Secondary vocational education?
Provide a succinct answer. 2.87. What is the difference between the highest and the lowest Female students (as % of total students) in Primary education?
Ensure brevity in your answer.  15.69. What is the difference between the highest and the lowest Female students (as % of total students) of Tertiary education?
Provide a succinct answer. 22.61. What is the difference between the highest and the lowest Female students (as % of total students) in Secondary general education?
Provide a succinct answer. 29.49. What is the difference between the highest and the lowest Female students (as % of total students) of Secondary vocational education?
Your response must be concise. 26.65. 